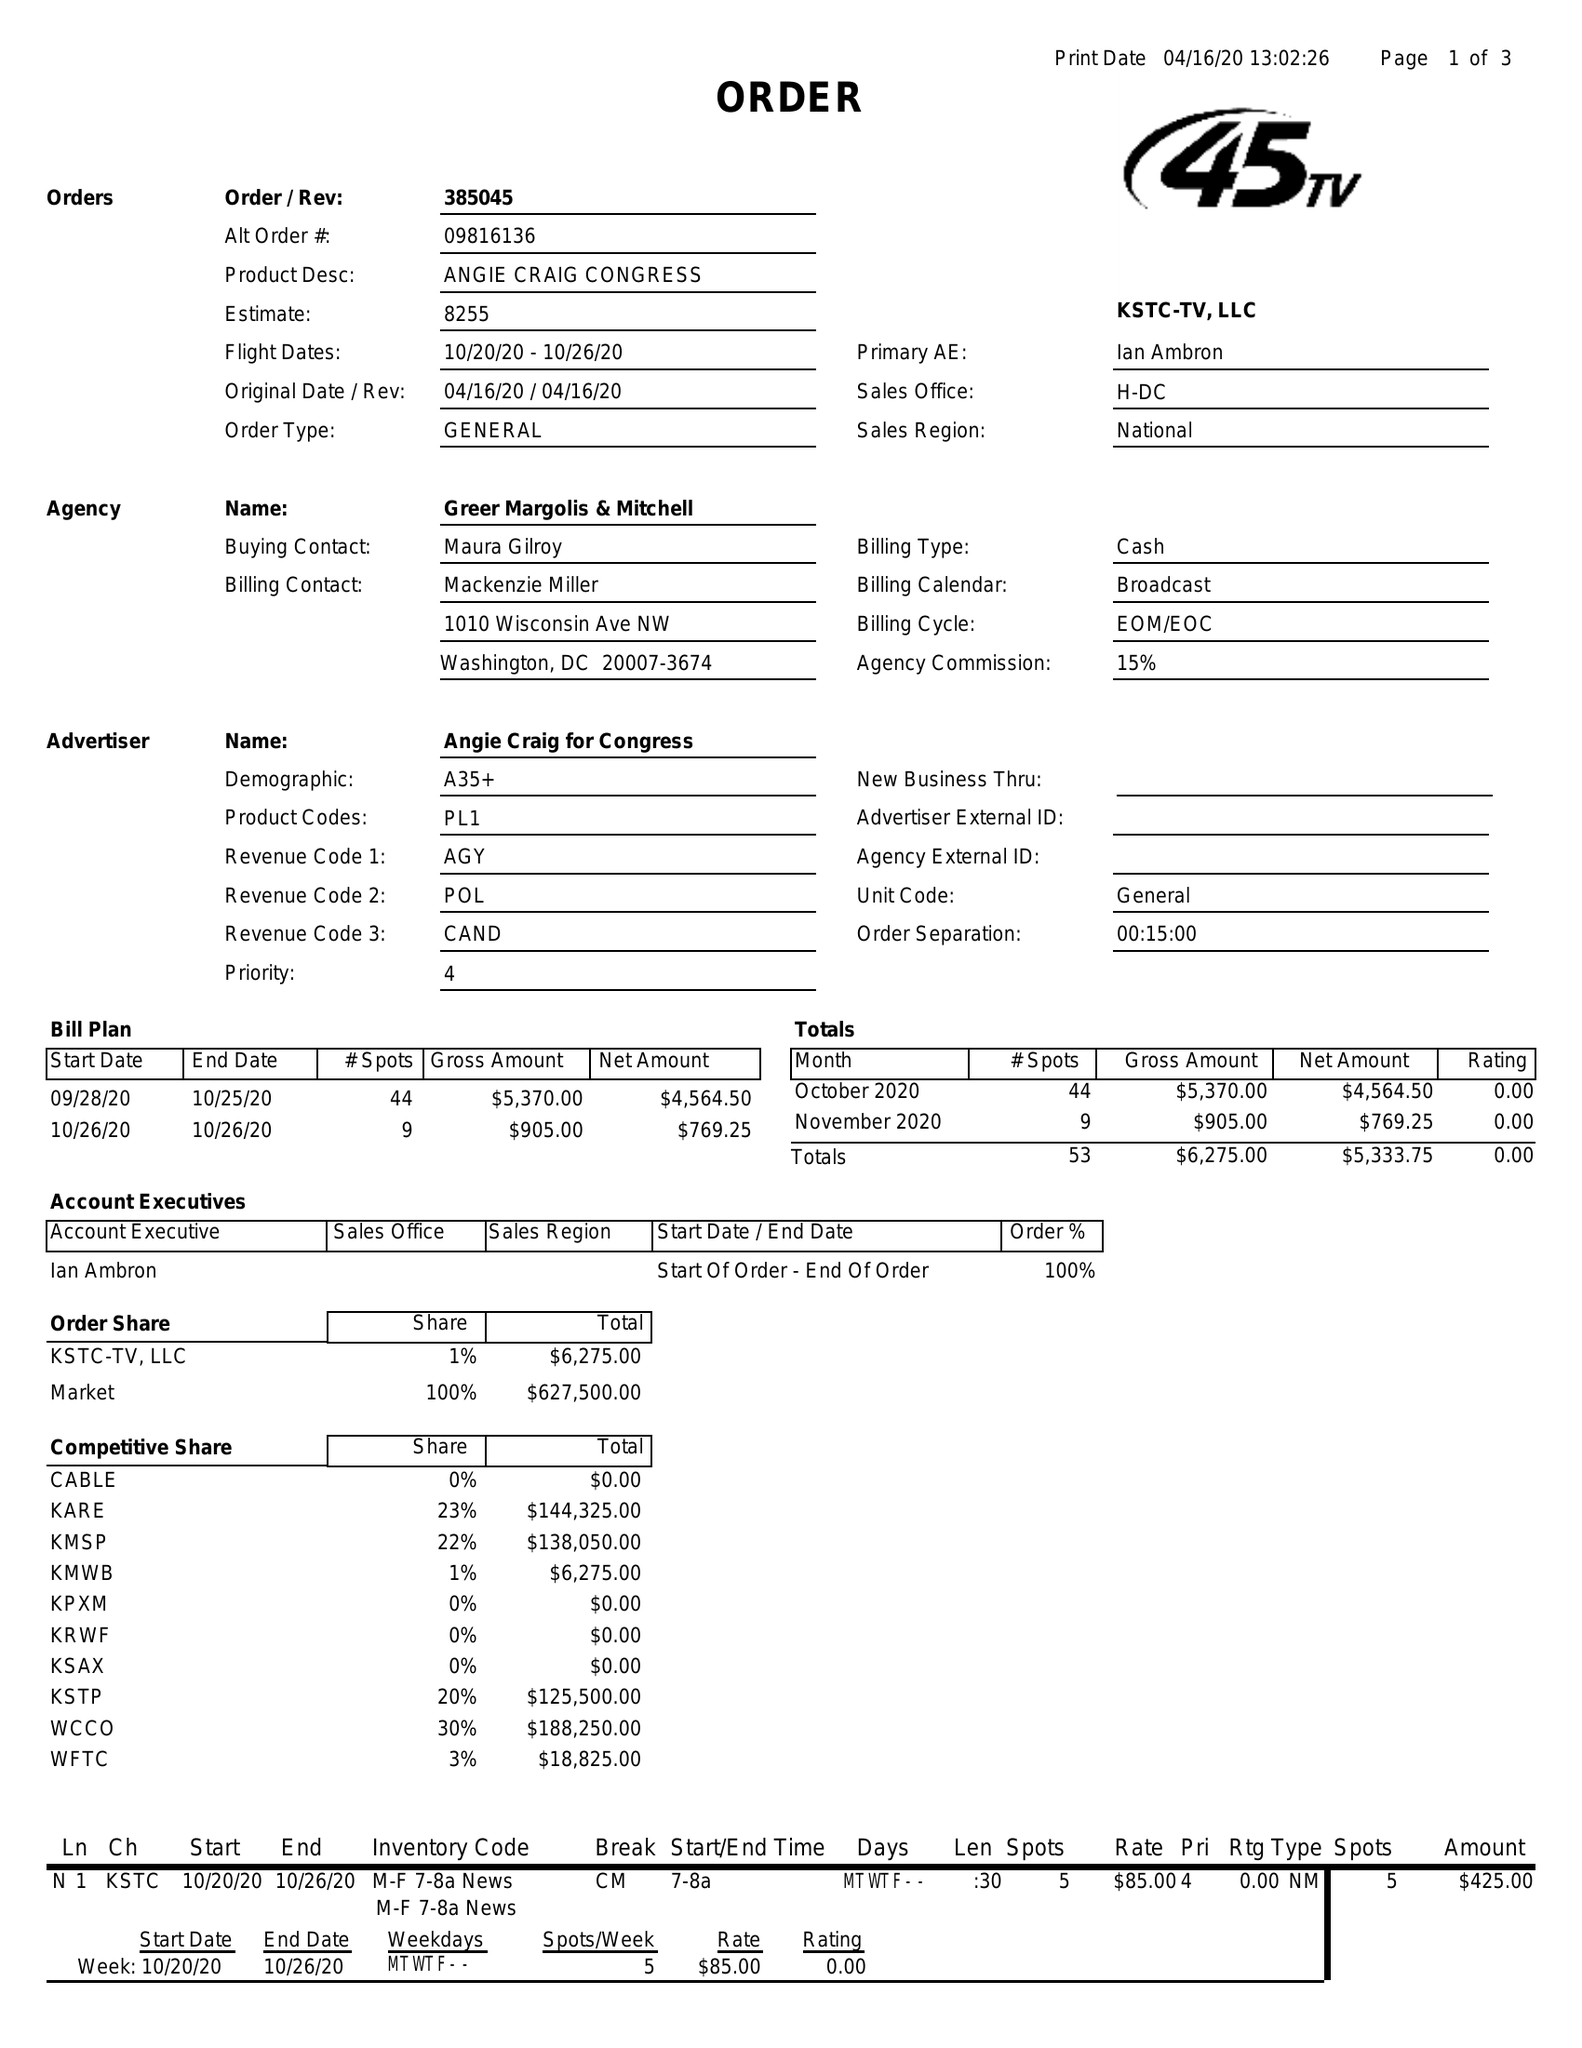What is the value for the advertiser?
Answer the question using a single word or phrase. ANGIE CRAIG FOR CONGRESS 